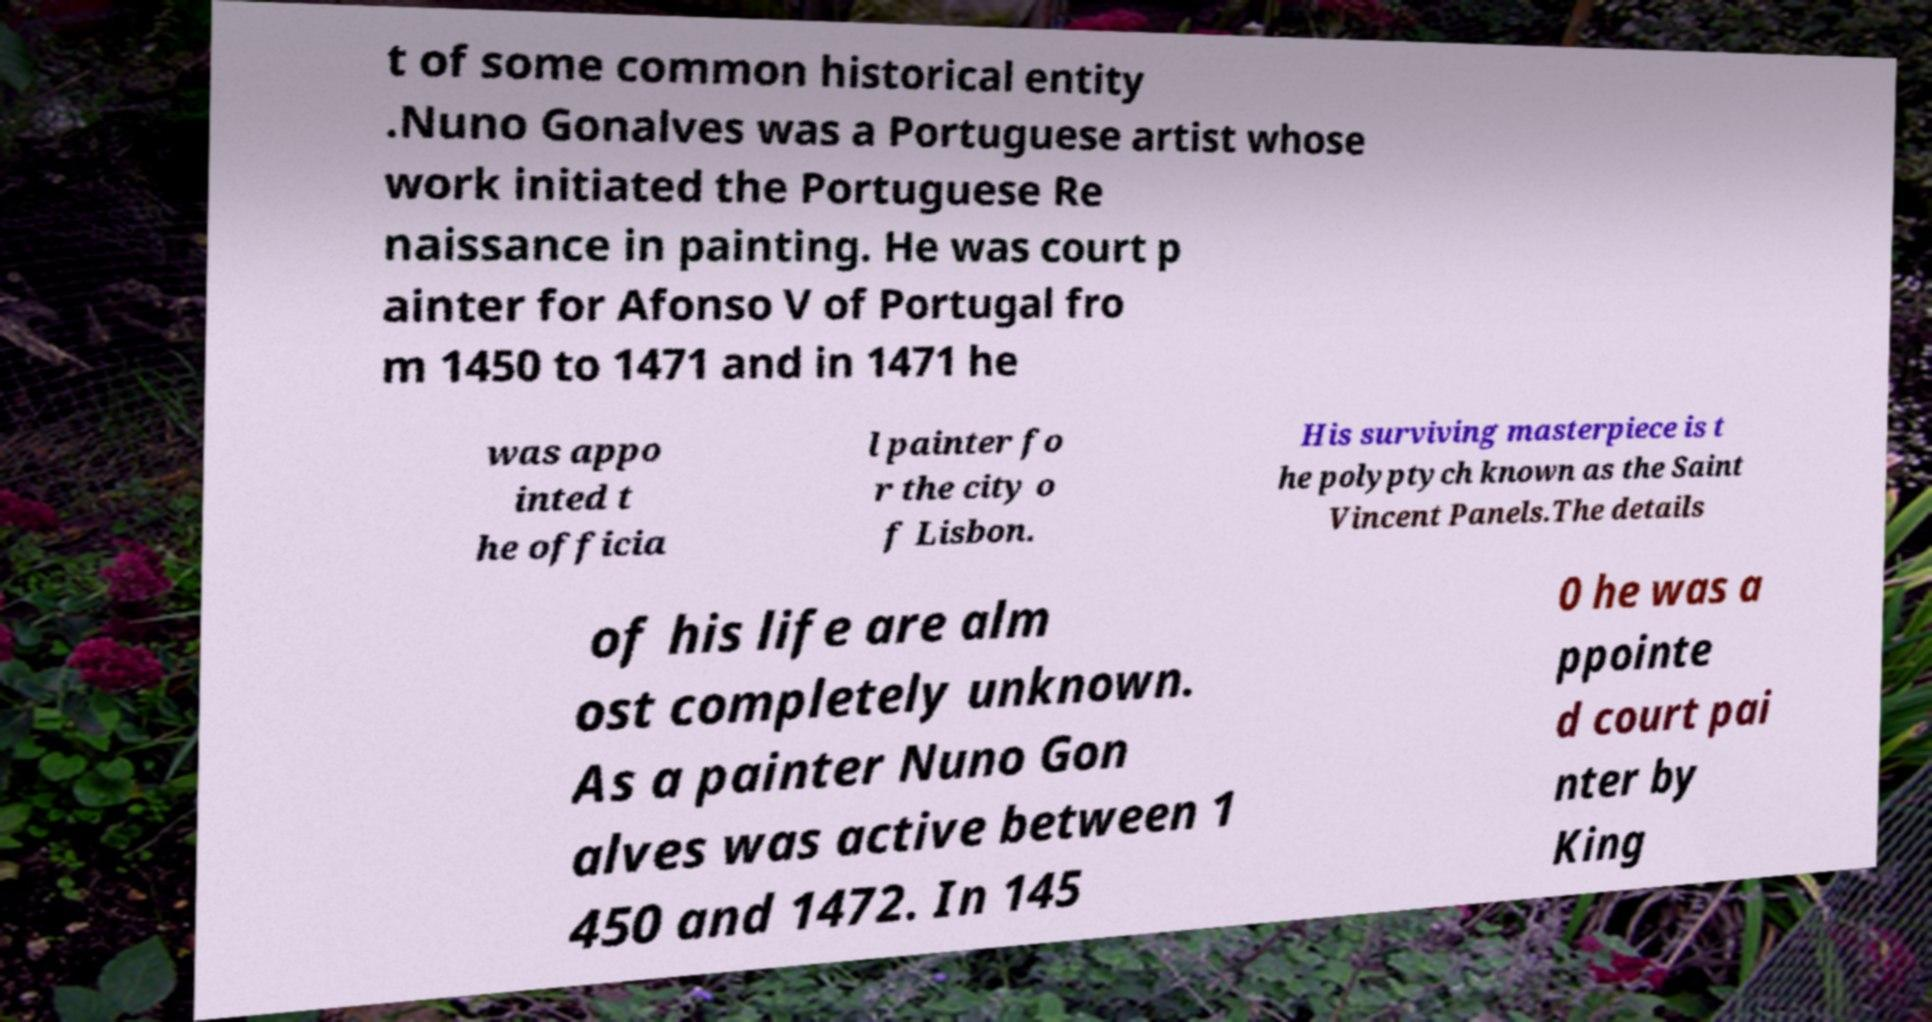Can you accurately transcribe the text from the provided image for me? t of some common historical entity .Nuno Gonalves was a Portuguese artist whose work initiated the Portuguese Re naissance in painting. He was court p ainter for Afonso V of Portugal fro m 1450 to 1471 and in 1471 he was appo inted t he officia l painter fo r the city o f Lisbon. His surviving masterpiece is t he polyptych known as the Saint Vincent Panels.The details of his life are alm ost completely unknown. As a painter Nuno Gon alves was active between 1 450 and 1472. In 145 0 he was a ppointe d court pai nter by King 